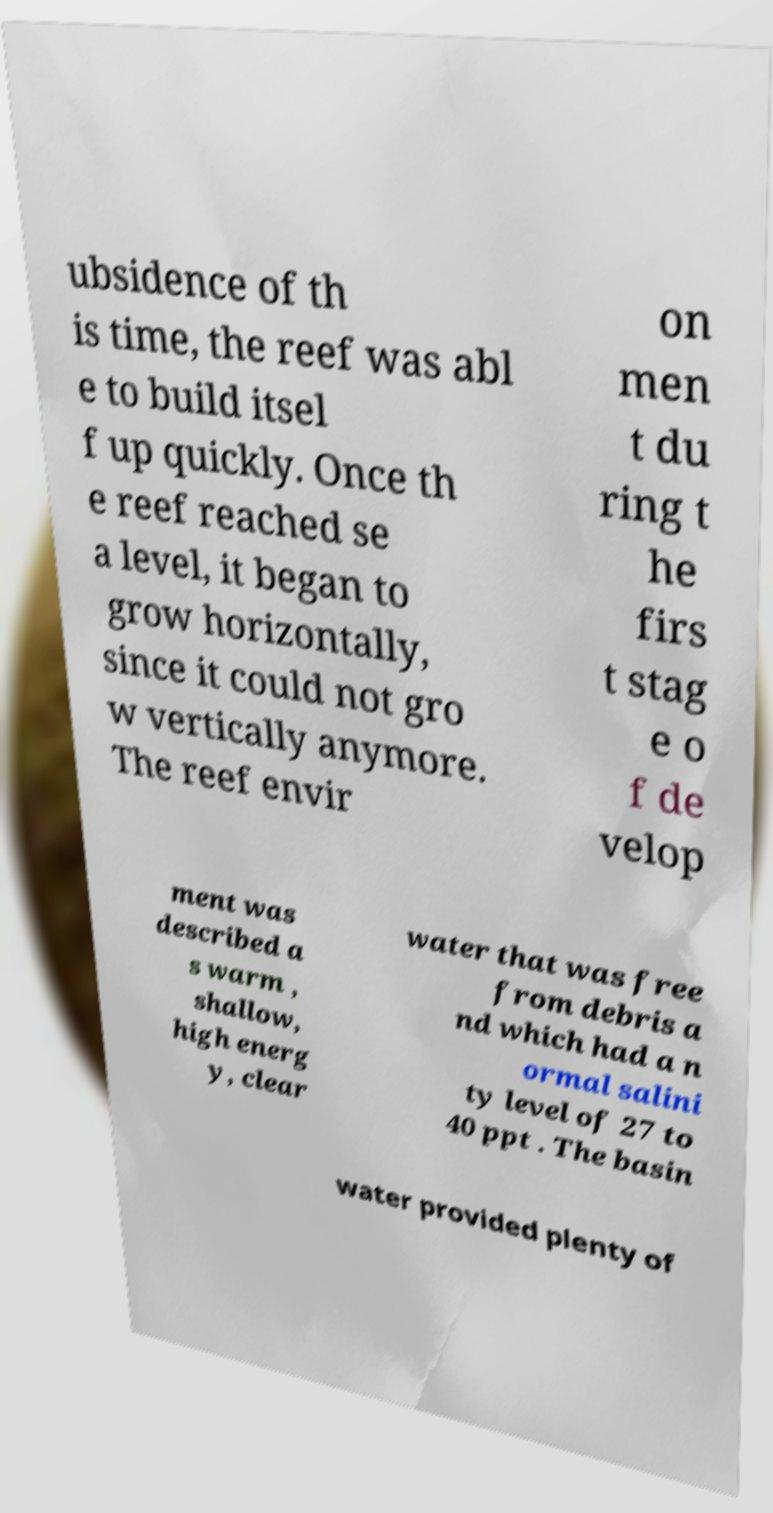Please identify and transcribe the text found in this image. ubsidence of th is time, the reef was abl e to build itsel f up quickly. Once th e reef reached se a level, it began to grow horizontally, since it could not gro w vertically anymore. The reef envir on men t du ring t he firs t stag e o f de velop ment was described a s warm , shallow, high energ y, clear water that was free from debris a nd which had a n ormal salini ty level of 27 to 40 ppt . The basin water provided plenty of 